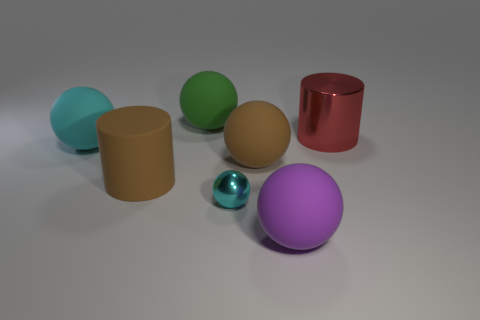Are there any blue blocks that have the same size as the green sphere?
Ensure brevity in your answer.  No. Is the number of large brown matte objects right of the green rubber sphere greater than the number of matte cylinders that are in front of the metal sphere?
Provide a short and direct response. Yes. Is the material of the large brown thing that is left of the small shiny sphere the same as the cyan ball right of the cyan rubber object?
Your response must be concise. No. There is a cyan object that is the same size as the green sphere; what shape is it?
Provide a succinct answer. Sphere. Are there any red shiny things of the same shape as the purple object?
Your answer should be very brief. No. There is a object that is in front of the small object; is it the same color as the cylinder that is to the left of the brown rubber ball?
Offer a very short reply. No. There is a cyan matte sphere; are there any big rubber things to the right of it?
Offer a very short reply. Yes. What is the material of the big thing that is both on the right side of the green rubber sphere and left of the big purple ball?
Make the answer very short. Rubber. Are the cyan ball behind the brown rubber cylinder and the large green thing made of the same material?
Provide a short and direct response. Yes. What is the material of the green ball?
Your answer should be compact. Rubber. 